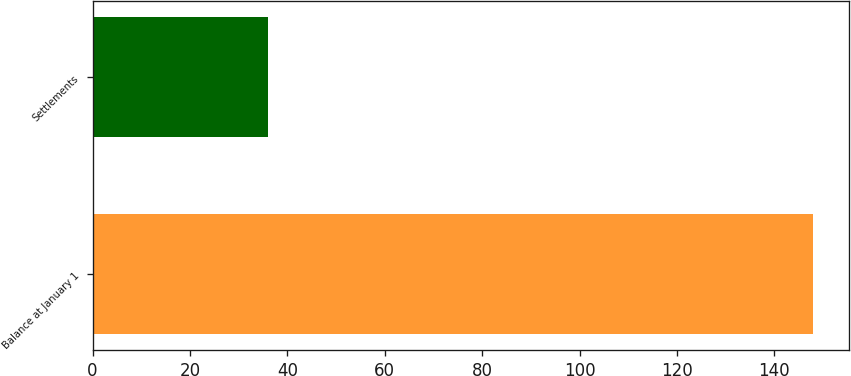Convert chart. <chart><loc_0><loc_0><loc_500><loc_500><bar_chart><fcel>Balance at January 1<fcel>Settlements<nl><fcel>148<fcel>36<nl></chart> 